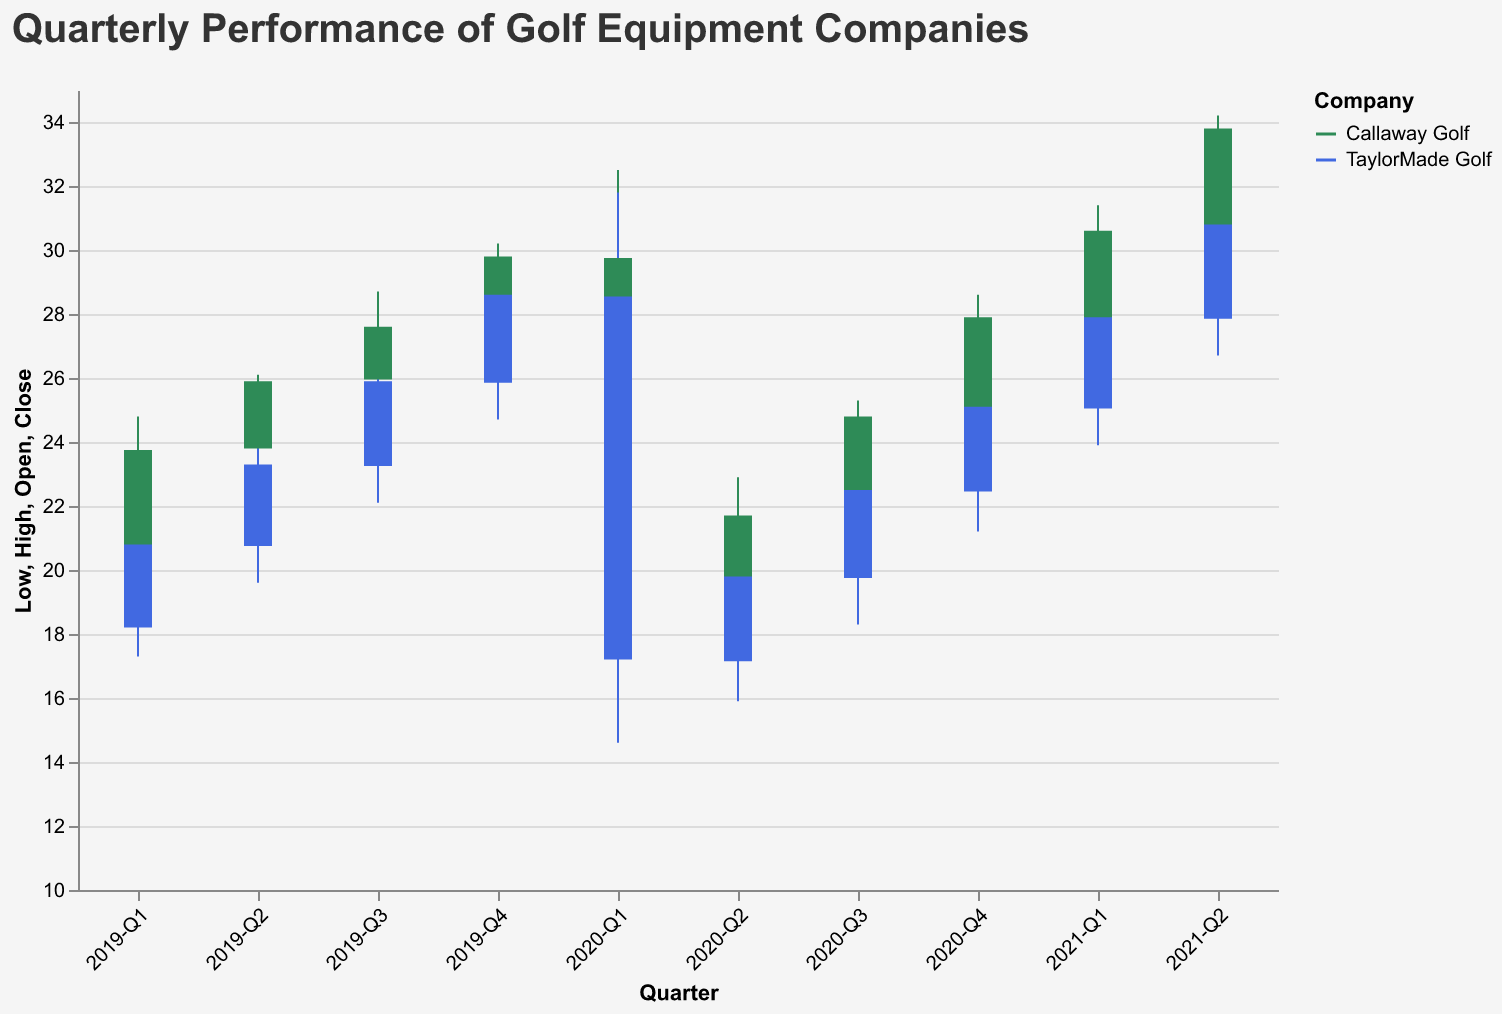What's the title of the chart? The title of the chart is displayed at the top of the figure, which provides a general description of what the chart represents.
Answer: Quarterly Performance of Golf Equipment Companies What are the names of the golf equipment companies included in the chart? The chart uses color to differentiate between the two companies. The companies are identified in the legend along with their corresponding colors.
Answer: Callaway Golf and TaylorMade Golf In which quarter did Callaway Golf have the lowest closing price? Look at the vertical placement of Callaway Golf's bars for each quarter and identify the lowest closing price. This will be in 2020-Q1, where the closing price is $18.40.
Answer: 2020-Q1 What is the trend for TaylorMade Golf from 2020-Q1 to 2020-Q4 in terms of closing prices? Observe the closing prices for TaylorMade Golf from 2020-Q1 to 2020-Q4. The closing prices increase from 2020-Q1 ($17.20) to 2020-Q2 ($19.80), to 2020-Q3 ($22.50), and then to 2020-Q4 ($25.10).
Answer: Upward trend Which company had a higher high price in 2020-Q2? Compare the high prices for both companies in 2020-Q2. Callaway Golf had a high price of $22.90, and TaylorMade Golf had a high price of $20.40.
Answer: Callaway Golf What is the difference between the high price and low price for Callaway Golf in 2020-Q1? Subtract the low price from the high price for Callaway Golf in 2020-Q1. High is $32.50, and low is $15.20, so the difference is $32.50 - $15.20.
Answer: $17.30 When did TaylorMade Golf have the highest closing price? Review the closing prices for TaylorMade Golf across all quarters and identify the highest value, which occurs in 2021-Q2 with a closing price of $30.80.
Answer: 2021-Q2 How did the low prices for Callaway Golf change from 2019-Q1 to 2021-Q2? Observe the low prices for Callaway Golf sequentially from 2019-Q1 to 2021-Q2: $18.90, $21.50, $23.80, $26.10, $15.20, $16.80, $19.40, $23.10, $26.20, $29.10. The trend includes a sharp drop in 2020-Q1 but generally increases over time.
Answer: Initially increases, sharp drop in 2020-Q1, then generally increasing Between Callaway Golf and TaylorMade Golf, which company had a greater range of high prices in 2019? Compare the high prices from 2019-Q1 to 2019-Q4 for both companies. Callaway Golf ranges from $24.80 to $30.20, a difference of $5.40. TaylorMade Golf ranges from $21.50 to $29.30, a difference of $7.80.
Answer: TaylorMade Golf What are the high and low prices for TaylorMade Golf in 2020-Q1? The chart shows the high and low prices for TaylorMade Golf in 2020-Q1 are $31.80 and $14.60, respectively.
Answer: $31.80 (high), $14.60 (low) 